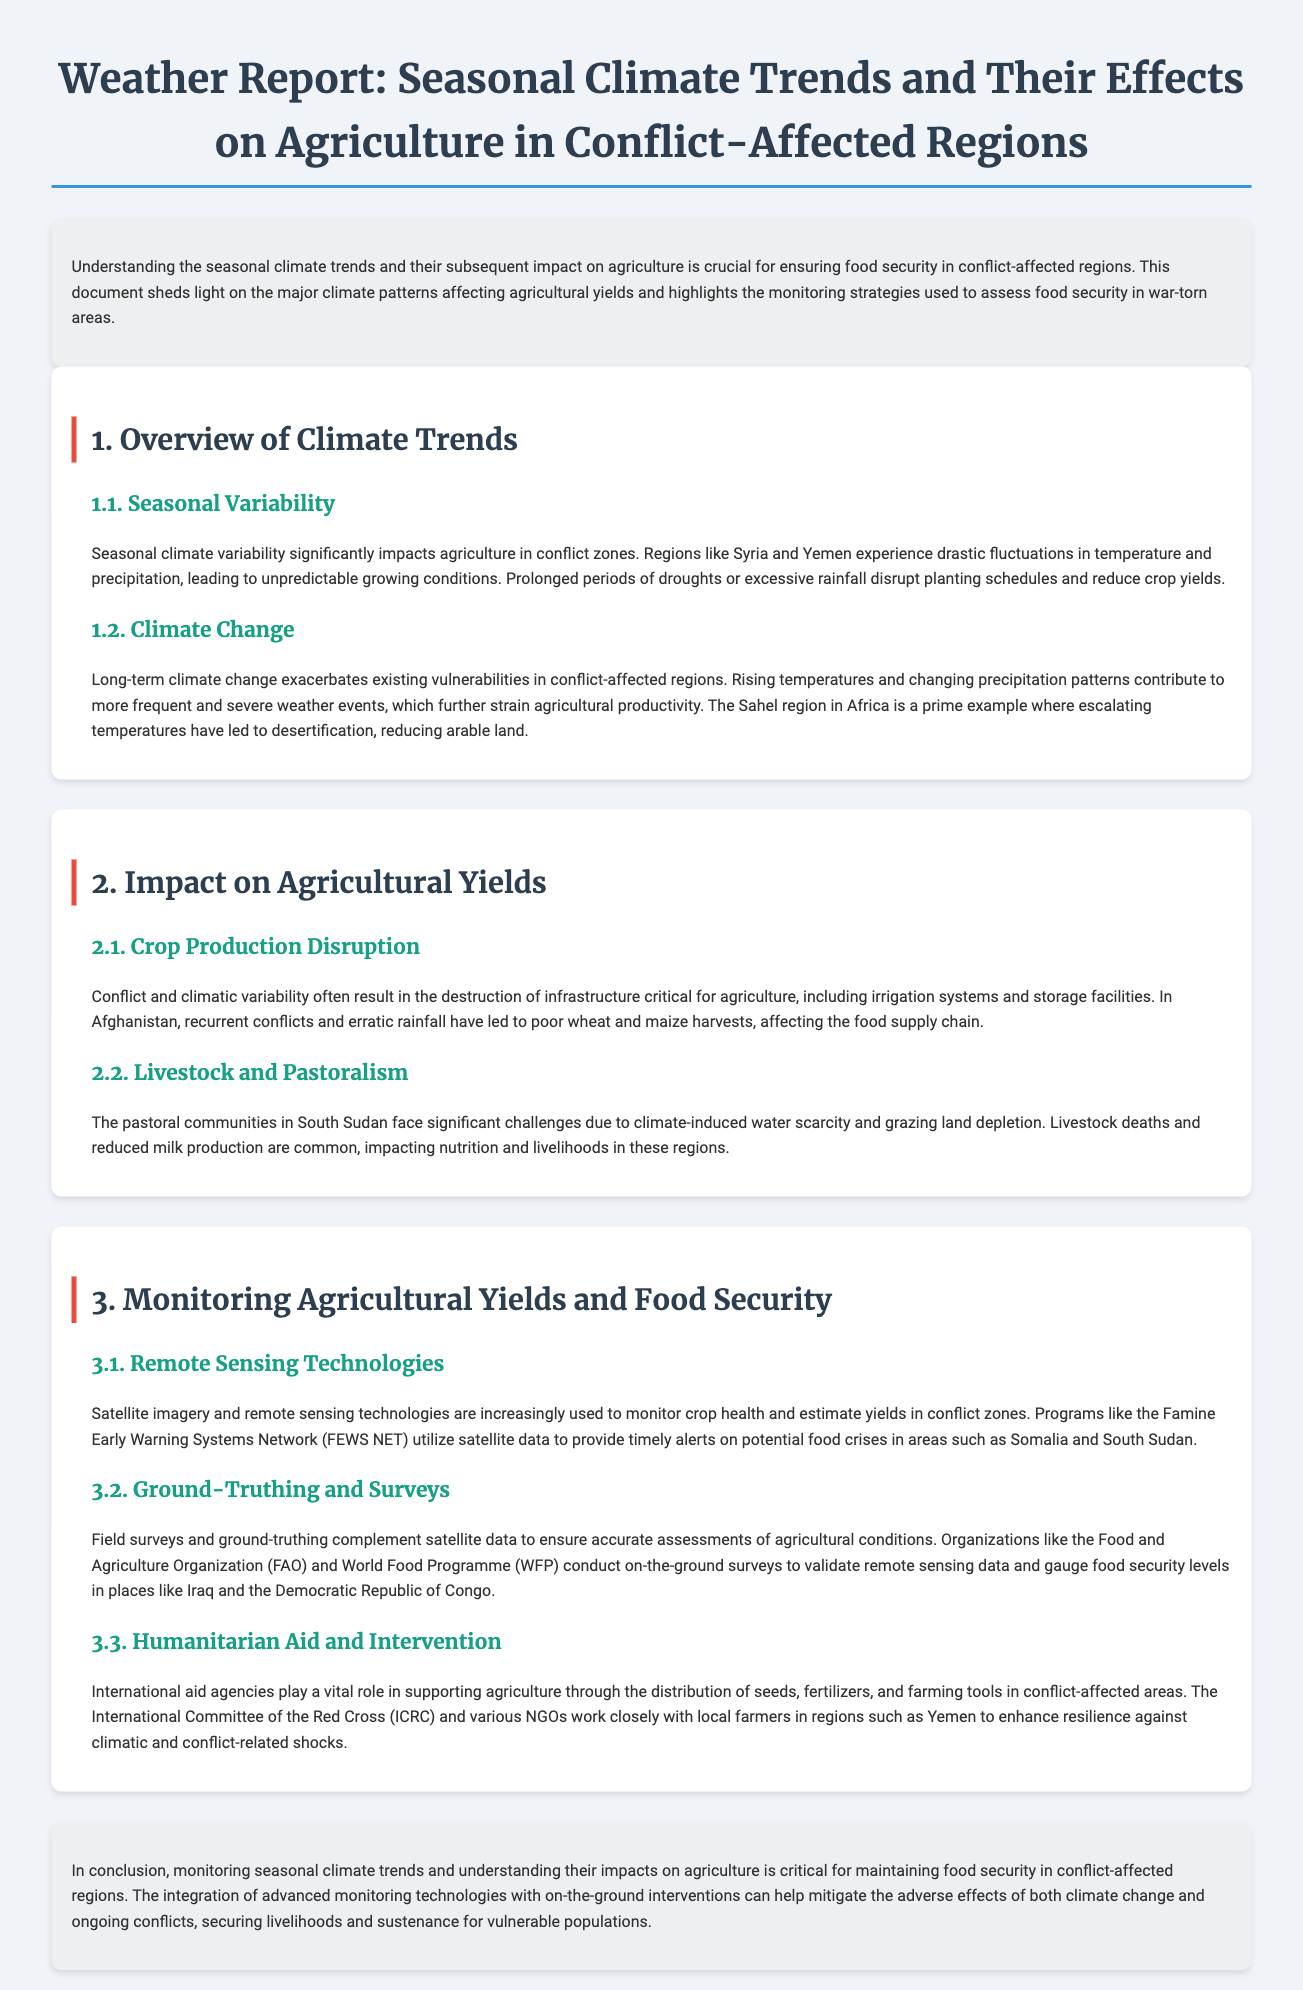What regions are mentioned as experiencing seasonal climate variability? The regions mentioned that experience seasonal climate variability are Syria and Yemen.
Answer: Syria and Yemen What does climate change contribute to in conflict-affected regions? Climate change contributes to more frequent and severe weather events, exacerbating existing vulnerabilities.
Answer: More severe weather events How does prolonged drought affect agricultural yields? Prolonged periods of drought disrupt planting schedules and reduce crop yields.
Answer: Reduces crop yields Which monitoring technology is used to estimate yields in conflict zones? Satellite imagery and remote sensing technologies are used to monitor crop health and estimate yields.
Answer: Satellite imagery What is the role of the International Committee of the Red Cross? The International Committee of the Red Cross supports agriculture through the distribution of seeds, fertilizers, and farming tools.
Answer: Support agriculture How does ground-truthing complement remote sensing data? Ground-truthing complements satellite data to ensure accurate assessments of agricultural conditions.
Answer: Ensures accuracy What is the Famine Early Warning Systems Network? The Famine Early Warning Systems Network utilizes satellite data to provide timely alerts on potential food crises.
Answer: Timely alerts Which two organizations conduct on-the-ground surveys? The Food and Agriculture Organization and World Food Programme conduct on-the-ground surveys.
Answer: FAO and WFP What are the effects of water scarcity on livestock in South Sudan? Water scarcity leads to livestock deaths and reduced milk production, impacting nutrition and livelihoods.
Answer: Livestock deaths and reduced milk production 